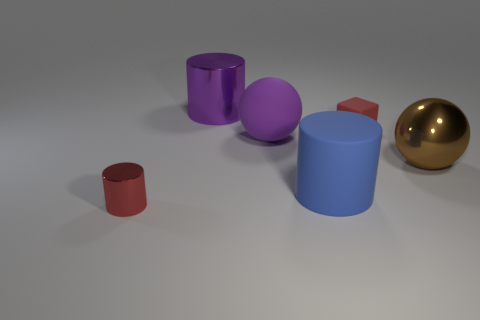Does the tiny matte thing have the same color as the small metallic thing?
Ensure brevity in your answer.  Yes. How big is the brown metallic ball that is behind the blue object?
Offer a very short reply. Large. Is there a purple matte cube that has the same size as the purple shiny cylinder?
Keep it short and to the point. No. Do the red metallic cylinder that is on the left side of the brown metallic sphere and the cube have the same size?
Provide a succinct answer. Yes. The purple cylinder is what size?
Your response must be concise. Large. What is the color of the thing that is left of the cylinder that is behind the big ball that is on the left side of the red rubber cube?
Provide a short and direct response. Red. There is a small thing that is right of the small red metallic cylinder; is its color the same as the tiny metal cylinder?
Your answer should be compact. Yes. How many things are both in front of the red cube and to the left of the big blue rubber thing?
Keep it short and to the point. 2. There is another thing that is the same shape as the large brown object; what is its size?
Offer a very short reply. Large. What number of big shiny cylinders are in front of the metallic sphere that is in front of the large sphere that is on the left side of the rubber cylinder?
Your response must be concise. 0. 